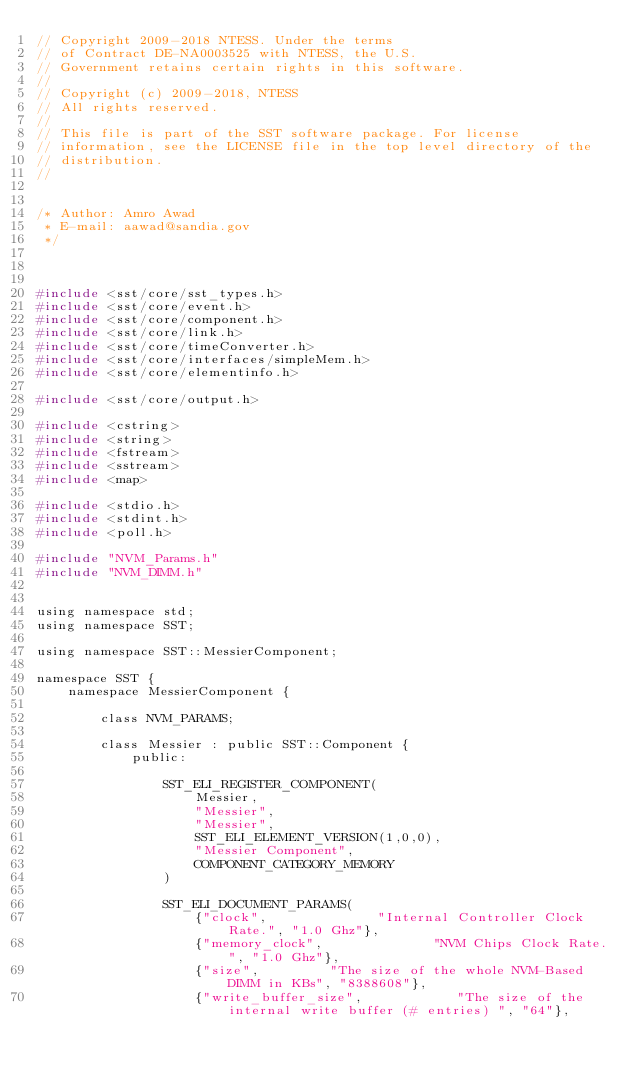<code> <loc_0><loc_0><loc_500><loc_500><_C_>// Copyright 2009-2018 NTESS. Under the terms
// of Contract DE-NA0003525 with NTESS, the U.S.
// Government retains certain rights in this software.
// 
// Copyright (c) 2009-2018, NTESS
// All rights reserved.
// 
// This file is part of the SST software package. For license
// information, see the LICENSE file in the top level directory of the
// distribution.
//


/* Author: Amro Awad
 * E-mail: aawad@sandia.gov
 */



#include <sst/core/sst_types.h>
#include <sst/core/event.h>
#include <sst/core/component.h>
#include <sst/core/link.h>
#include <sst/core/timeConverter.h>
#include <sst/core/interfaces/simpleMem.h>
#include <sst/core/elementinfo.h>

#include <sst/core/output.h>

#include <cstring>
#include <string>
#include <fstream>
#include <sstream>
#include <map>

#include <stdio.h>
#include <stdint.h>
#include <poll.h>

#include "NVM_Params.h"
#include "NVM_DIMM.h"


using namespace std;
using namespace SST;

using namespace SST::MessierComponent;

namespace SST {
	namespace MessierComponent {

		class NVM_PARAMS;

		class Messier : public SST::Component {
			public:

                SST_ELI_REGISTER_COMPONENT(
                    Messier,
                    "Messier",
                    "Messier",
                    SST_ELI_ELEMENT_VERSION(1,0,0),
                    "Messier Component",
                    COMPONENT_CATEGORY_MEMORY
                )

                SST_ELI_DOCUMENT_PARAMS(
                    {"clock",              "Internal Controller Clock Rate.", "1.0 Ghz"},
                    {"memory_clock",              "NVM Chips Clock Rate.", "1.0 Ghz"},
                    {"size",         "The size of the whole NVM-Based DIMM in KBs", "8388608"},
                    {"write_buffer_size",            "The size of the internal write buffer (# entries) ", "64"},</code> 